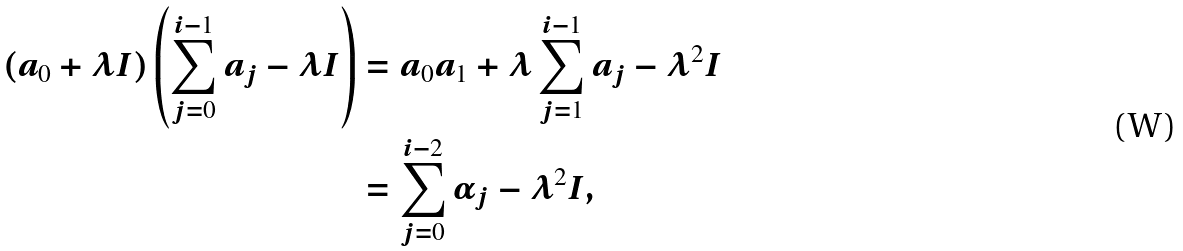<formula> <loc_0><loc_0><loc_500><loc_500>( a _ { 0 } + \lambda I ) \left ( \sum _ { j = 0 } ^ { i - 1 } a _ { j } - \lambda I \right ) & = a _ { 0 } a _ { 1 } + \lambda \sum _ { j = 1 } ^ { i - 1 } a _ { j } - \lambda ^ { 2 } I \\ & = \sum _ { j = 0 } ^ { i - 2 } \alpha _ { j } - \lambda ^ { 2 } I ,</formula> 